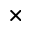<formula> <loc_0><loc_0><loc_500><loc_500>\times</formula> 